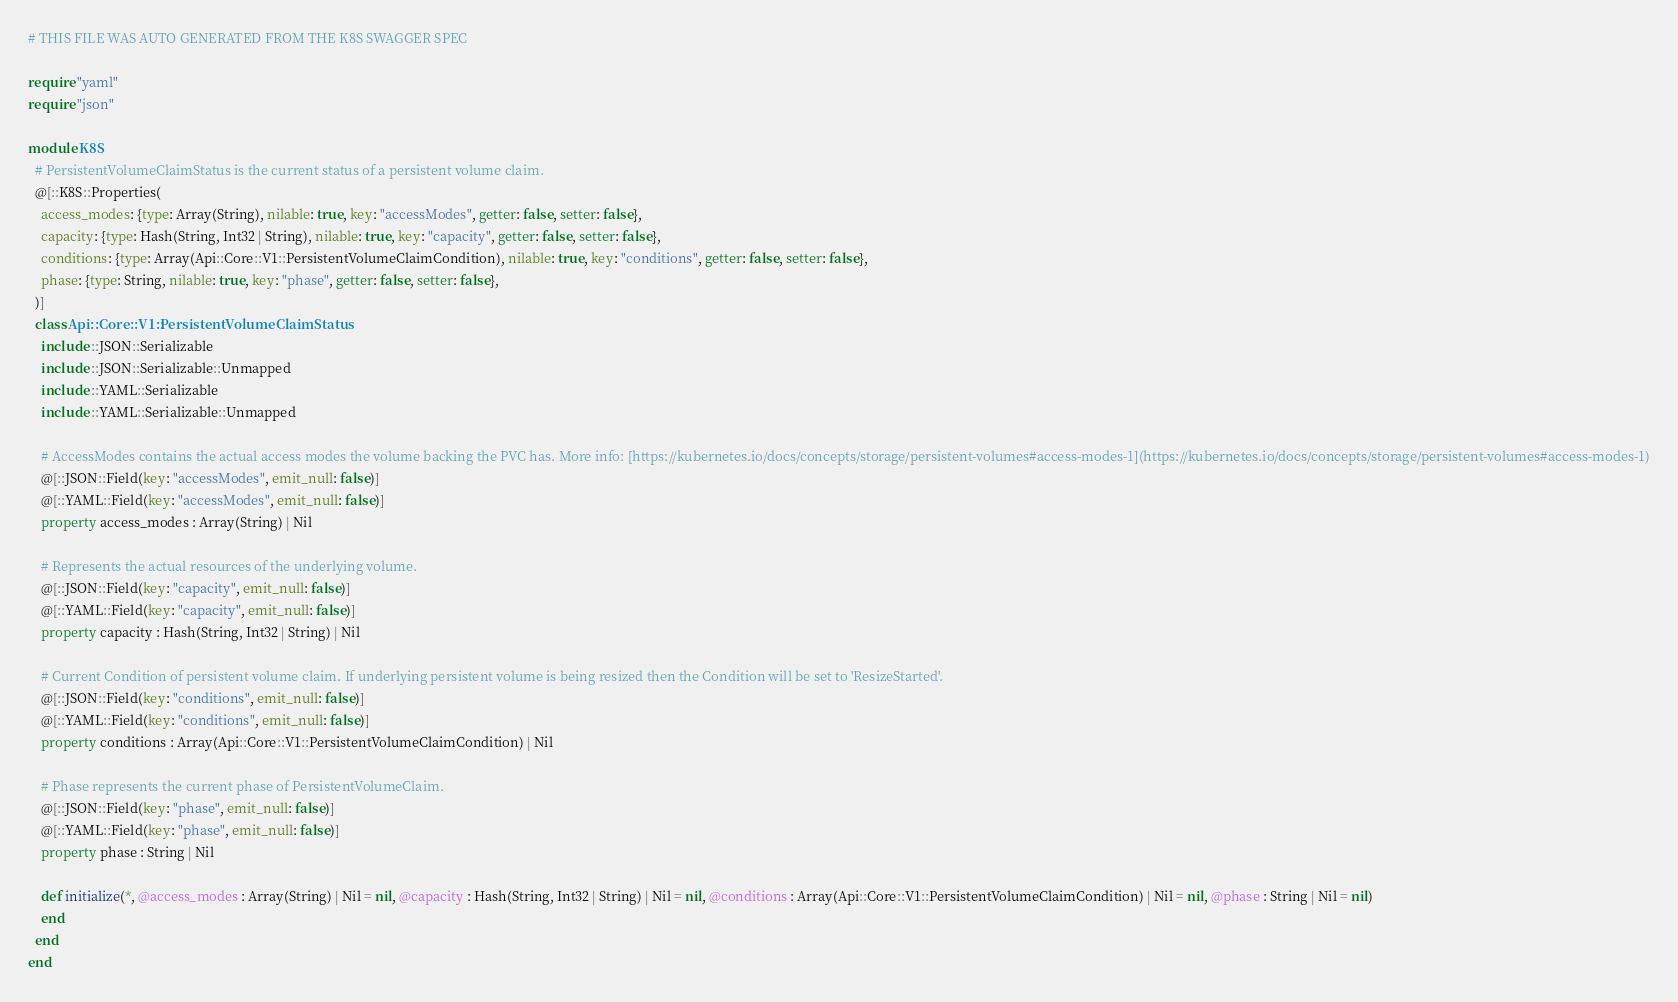Convert code to text. <code><loc_0><loc_0><loc_500><loc_500><_Crystal_># THIS FILE WAS AUTO GENERATED FROM THE K8S SWAGGER SPEC

require "yaml"
require "json"

module K8S
  # PersistentVolumeClaimStatus is the current status of a persistent volume claim.
  @[::K8S::Properties(
    access_modes: {type: Array(String), nilable: true, key: "accessModes", getter: false, setter: false},
    capacity: {type: Hash(String, Int32 | String), nilable: true, key: "capacity", getter: false, setter: false},
    conditions: {type: Array(Api::Core::V1::PersistentVolumeClaimCondition), nilable: true, key: "conditions", getter: false, setter: false},
    phase: {type: String, nilable: true, key: "phase", getter: false, setter: false},
  )]
  class Api::Core::V1::PersistentVolumeClaimStatus
    include ::JSON::Serializable
    include ::JSON::Serializable::Unmapped
    include ::YAML::Serializable
    include ::YAML::Serializable::Unmapped

    # AccessModes contains the actual access modes the volume backing the PVC has. More info: [https://kubernetes.io/docs/concepts/storage/persistent-volumes#access-modes-1](https://kubernetes.io/docs/concepts/storage/persistent-volumes#access-modes-1)
    @[::JSON::Field(key: "accessModes", emit_null: false)]
    @[::YAML::Field(key: "accessModes", emit_null: false)]
    property access_modes : Array(String) | Nil

    # Represents the actual resources of the underlying volume.
    @[::JSON::Field(key: "capacity", emit_null: false)]
    @[::YAML::Field(key: "capacity", emit_null: false)]
    property capacity : Hash(String, Int32 | String) | Nil

    # Current Condition of persistent volume claim. If underlying persistent volume is being resized then the Condition will be set to 'ResizeStarted'.
    @[::JSON::Field(key: "conditions", emit_null: false)]
    @[::YAML::Field(key: "conditions", emit_null: false)]
    property conditions : Array(Api::Core::V1::PersistentVolumeClaimCondition) | Nil

    # Phase represents the current phase of PersistentVolumeClaim.
    @[::JSON::Field(key: "phase", emit_null: false)]
    @[::YAML::Field(key: "phase", emit_null: false)]
    property phase : String | Nil

    def initialize(*, @access_modes : Array(String) | Nil = nil, @capacity : Hash(String, Int32 | String) | Nil = nil, @conditions : Array(Api::Core::V1::PersistentVolumeClaimCondition) | Nil = nil, @phase : String | Nil = nil)
    end
  end
end
</code> 